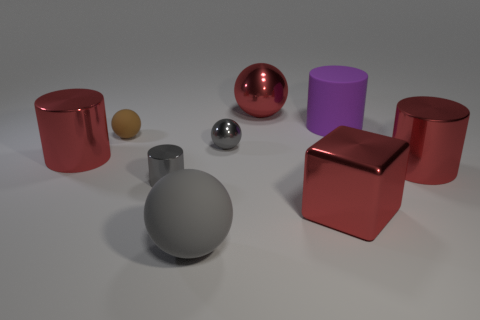Subtract 1 balls. How many balls are left? 3 Subtract all balls. How many objects are left? 5 Subtract all red metal cylinders. Subtract all rubber cylinders. How many objects are left? 6 Add 7 gray cylinders. How many gray cylinders are left? 8 Add 1 tiny brown objects. How many tiny brown objects exist? 2 Subtract 0 gray cubes. How many objects are left? 9 